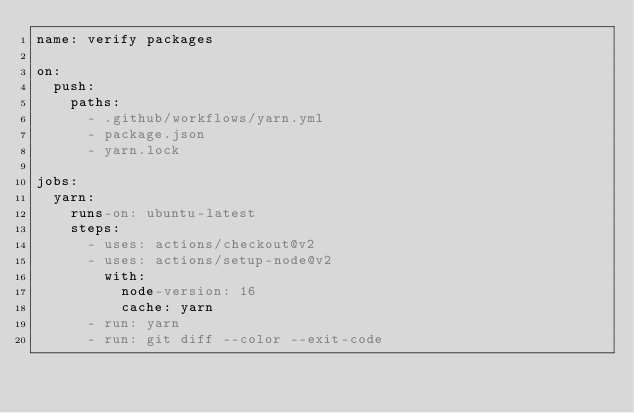<code> <loc_0><loc_0><loc_500><loc_500><_YAML_>name: verify packages

on:
  push:
    paths:
      - .github/workflows/yarn.yml
      - package.json
      - yarn.lock

jobs:
  yarn:
    runs-on: ubuntu-latest
    steps:
      - uses: actions/checkout@v2
      - uses: actions/setup-node@v2
        with:
          node-version: 16
          cache: yarn
      - run: yarn
      - run: git diff --color --exit-code
</code> 